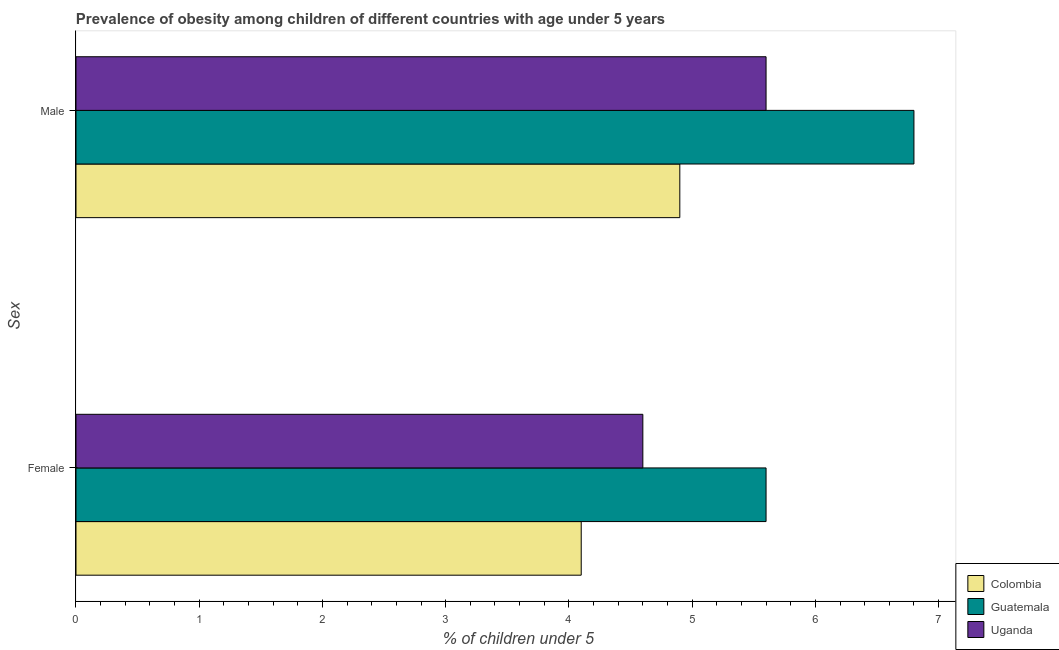How many different coloured bars are there?
Offer a terse response. 3. How many bars are there on the 2nd tick from the top?
Offer a very short reply. 3. What is the label of the 2nd group of bars from the top?
Give a very brief answer. Female. What is the percentage of obese male children in Colombia?
Your answer should be very brief. 4.9. Across all countries, what is the maximum percentage of obese male children?
Your answer should be very brief. 6.8. Across all countries, what is the minimum percentage of obese male children?
Ensure brevity in your answer.  4.9. In which country was the percentage of obese female children maximum?
Offer a very short reply. Guatemala. In which country was the percentage of obese female children minimum?
Your answer should be very brief. Colombia. What is the total percentage of obese female children in the graph?
Make the answer very short. 14.3. What is the difference between the percentage of obese male children in Guatemala and that in Colombia?
Keep it short and to the point. 1.9. What is the difference between the percentage of obese female children in Guatemala and the percentage of obese male children in Colombia?
Your answer should be compact. 0.7. What is the average percentage of obese male children per country?
Give a very brief answer. 5.77. What is the difference between the percentage of obese female children and percentage of obese male children in Uganda?
Your answer should be compact. -1. In how many countries, is the percentage of obese female children greater than 4.6 %?
Give a very brief answer. 1. What is the ratio of the percentage of obese male children in Guatemala to that in Colombia?
Your response must be concise. 1.39. Is the percentage of obese male children in Colombia less than that in Uganda?
Your answer should be very brief. Yes. In how many countries, is the percentage of obese male children greater than the average percentage of obese male children taken over all countries?
Make the answer very short. 1. What does the 1st bar from the top in Male represents?
Give a very brief answer. Uganda. What does the 2nd bar from the bottom in Male represents?
Offer a very short reply. Guatemala. How many bars are there?
Provide a short and direct response. 6. Are the values on the major ticks of X-axis written in scientific E-notation?
Offer a terse response. No. Does the graph contain any zero values?
Keep it short and to the point. No. Where does the legend appear in the graph?
Keep it short and to the point. Bottom right. What is the title of the graph?
Ensure brevity in your answer.  Prevalence of obesity among children of different countries with age under 5 years. Does "Equatorial Guinea" appear as one of the legend labels in the graph?
Offer a terse response. No. What is the label or title of the X-axis?
Your answer should be compact.  % of children under 5. What is the label or title of the Y-axis?
Make the answer very short. Sex. What is the  % of children under 5 in Colombia in Female?
Provide a succinct answer. 4.1. What is the  % of children under 5 in Guatemala in Female?
Ensure brevity in your answer.  5.6. What is the  % of children under 5 in Uganda in Female?
Provide a short and direct response. 4.6. What is the  % of children under 5 of Colombia in Male?
Provide a succinct answer. 4.9. What is the  % of children under 5 in Guatemala in Male?
Ensure brevity in your answer.  6.8. What is the  % of children under 5 in Uganda in Male?
Your answer should be very brief. 5.6. Across all Sex, what is the maximum  % of children under 5 of Colombia?
Make the answer very short. 4.9. Across all Sex, what is the maximum  % of children under 5 of Guatemala?
Make the answer very short. 6.8. Across all Sex, what is the maximum  % of children under 5 in Uganda?
Your answer should be compact. 5.6. Across all Sex, what is the minimum  % of children under 5 of Colombia?
Your answer should be compact. 4.1. Across all Sex, what is the minimum  % of children under 5 in Guatemala?
Ensure brevity in your answer.  5.6. Across all Sex, what is the minimum  % of children under 5 in Uganda?
Your response must be concise. 4.6. What is the difference between the  % of children under 5 of Guatemala in Female and that in Male?
Your answer should be very brief. -1.2. What is the difference between the  % of children under 5 of Uganda in Female and that in Male?
Your answer should be compact. -1. What is the difference between the  % of children under 5 of Colombia in Female and the  % of children under 5 of Uganda in Male?
Offer a terse response. -1.5. What is the average  % of children under 5 of Uganda per Sex?
Make the answer very short. 5.1. What is the difference between the  % of children under 5 in Colombia and  % of children under 5 in Guatemala in Female?
Your response must be concise. -1.5. What is the difference between the  % of children under 5 in Colombia and  % of children under 5 in Uganda in Female?
Give a very brief answer. -0.5. What is the ratio of the  % of children under 5 of Colombia in Female to that in Male?
Provide a succinct answer. 0.84. What is the ratio of the  % of children under 5 of Guatemala in Female to that in Male?
Your response must be concise. 0.82. What is the ratio of the  % of children under 5 in Uganda in Female to that in Male?
Keep it short and to the point. 0.82. What is the difference between the highest and the second highest  % of children under 5 of Colombia?
Give a very brief answer. 0.8. What is the difference between the highest and the second highest  % of children under 5 in Uganda?
Keep it short and to the point. 1. What is the difference between the highest and the lowest  % of children under 5 in Guatemala?
Offer a terse response. 1.2. 